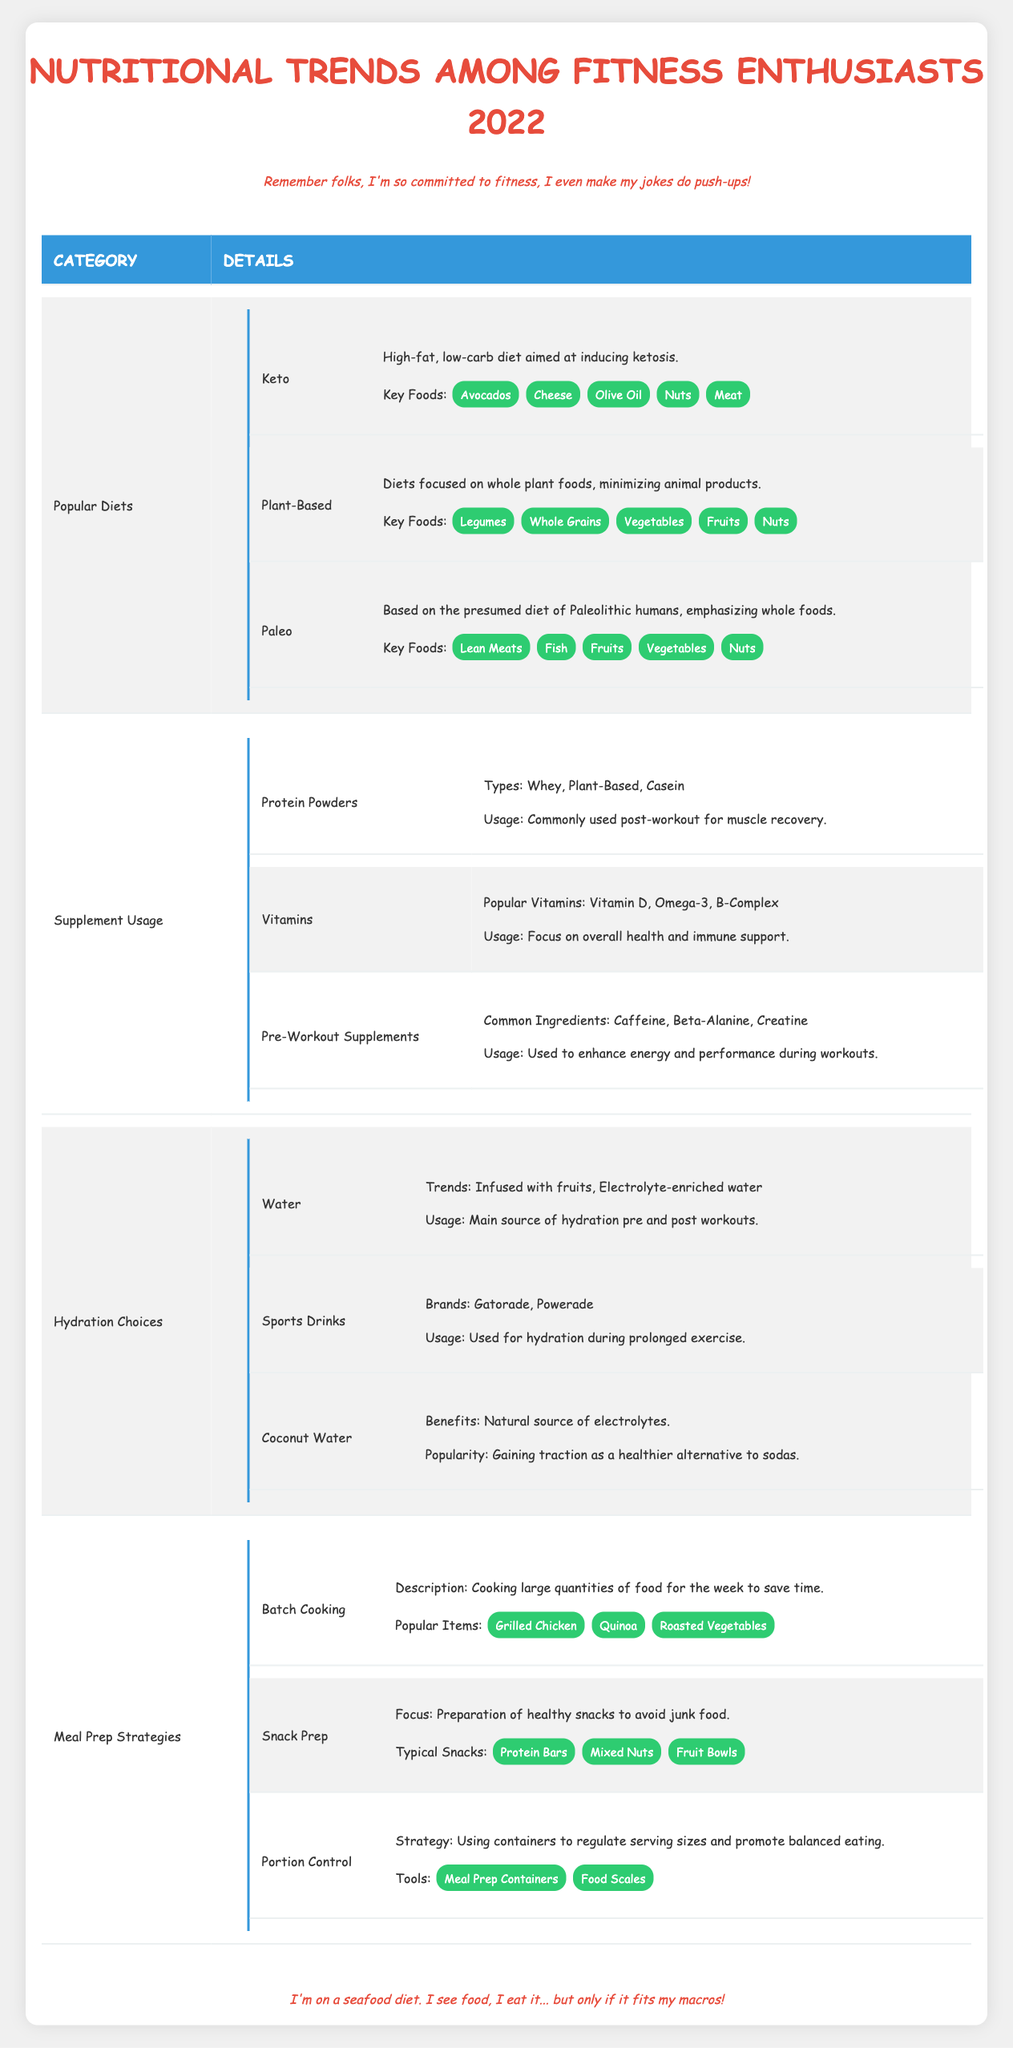What are the three popular diets among fitness enthusiasts in 2022? The table lists three popular diets: Keto, Plant-Based, and Paleo. Each diet is mentioned under the "Popular Diets" category.
Answer: Keto, Plant-Based, Paleo Which diet focuses on whole plant foods? The table states that the Plant-Based diet emphasizes whole plant foods while minimizing animal products, as described in the "Popular Diets" section.
Answer: Plant-Based True or False: Protein Powders are used during workouts. The table indicates that Protein Powders are most commonly used post-workout for muscle recovery, not during workouts. Therefore, the statement is false.
Answer: False What are the key foods associated with the Keto diet? Under the Keto diet section in the table, the key foods listed are Avocados, Cheese, Olive Oil, Nuts, and Meat.
Answer: Avocados, Cheese, Olive Oil, Nuts, Meat How many types of Protein Powders are mentioned, and what are they? The table specifies three types of Protein Powders: Whey, Plant-Based, and Casein. Therefore, the number is three, and they are listed under "Supplement Usage."
Answer: Three: Whey, Plant-Based, Casein Which hydration choice has gained popularity as a healthier alternative to sodas? According to the table under "Hydration Choices," Coconut Water is noted for gaining traction as a healthier alternative to sodas.
Answer: Coconut Water List the popular items in the Batch Cooking meal prep strategy. The Batch Cooking section of the table lists the popular items as Grilled Chicken, Quinoa, and Roasted Vegetables.
Answer: Grilled Chicken, Quinoa, Roasted Vegetables What ingredient is commonly found in Pre-Workout Supplements? The table outlines common ingredients in Pre-Workout Supplements as Caffeine, Beta-Alanine, and Creatine; any of these can be identified as common.
Answer: Caffeine, Beta-Alanine, Creatine How do popular vitamins focus according to fitness enthusiasts in 2022? The table mentions that the focus of popular vitamins like Vitamin D, Omega-3, and B-Complex is on overall health and immune support, as detailed in the "Vitamins" section under "Supplement Usage."
Answer: Overall health and immune support 